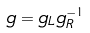Convert formula to latex. <formula><loc_0><loc_0><loc_500><loc_500>g = g _ { L } g _ { R } ^ { - 1 }</formula> 